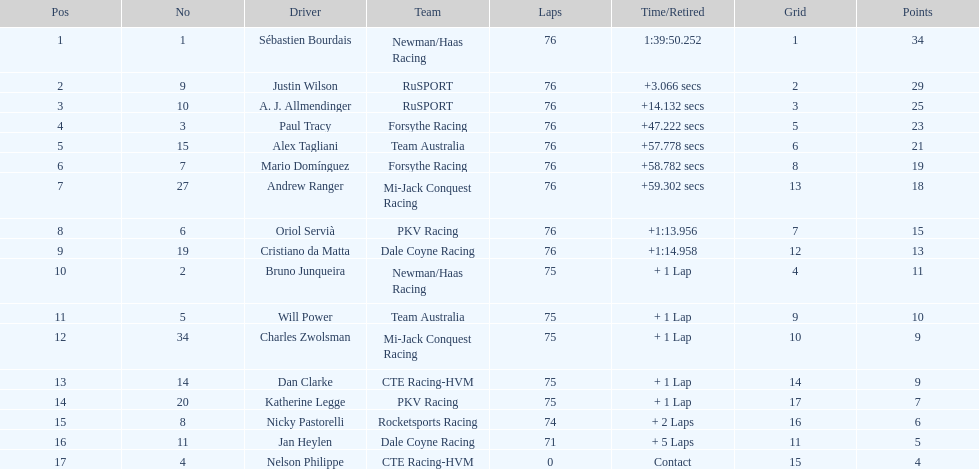Which driver holds the smallest number of points? Nelson Philippe. 